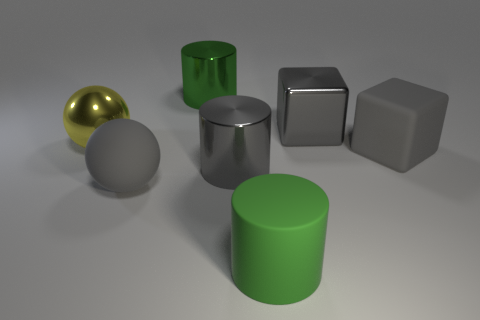Is the gray cylinder the same size as the rubber ball?
Keep it short and to the point. Yes. Are there any gray rubber objects that are right of the gray cube in front of the yellow ball that is on the left side of the large matte cube?
Provide a short and direct response. No. What material is the other big thing that is the same shape as the large yellow shiny object?
Ensure brevity in your answer.  Rubber. What number of gray balls are behind the shiny thing in front of the large yellow metallic thing?
Keep it short and to the point. 0. How big is the gray matte object to the right of the metallic object in front of the big gray matte thing right of the gray rubber ball?
Make the answer very short. Large. The ball that is in front of the large gray shiny cylinder behind the gray rubber sphere is what color?
Offer a terse response. Gray. What number of other objects are there of the same material as the gray cylinder?
Provide a succinct answer. 3. How many other things are the same color as the large metal ball?
Provide a succinct answer. 0. The gray object behind the large matte block in front of the shiny ball is made of what material?
Provide a short and direct response. Metal. Are there any gray metal objects?
Give a very brief answer. Yes. 